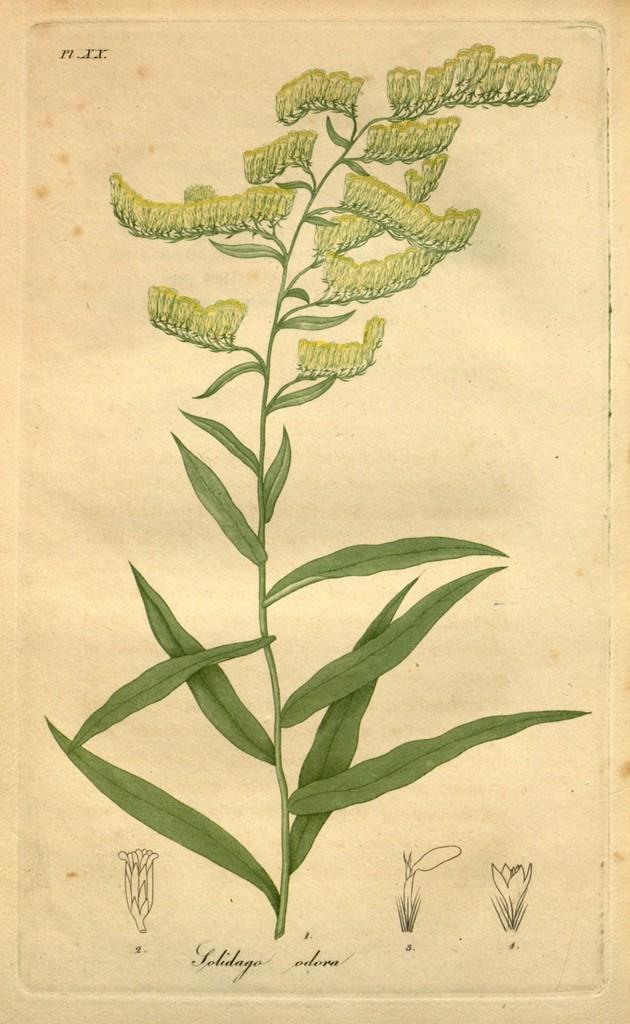How would you summarize this image in a sentence or two? This picture consist of a plant on page in the image. 